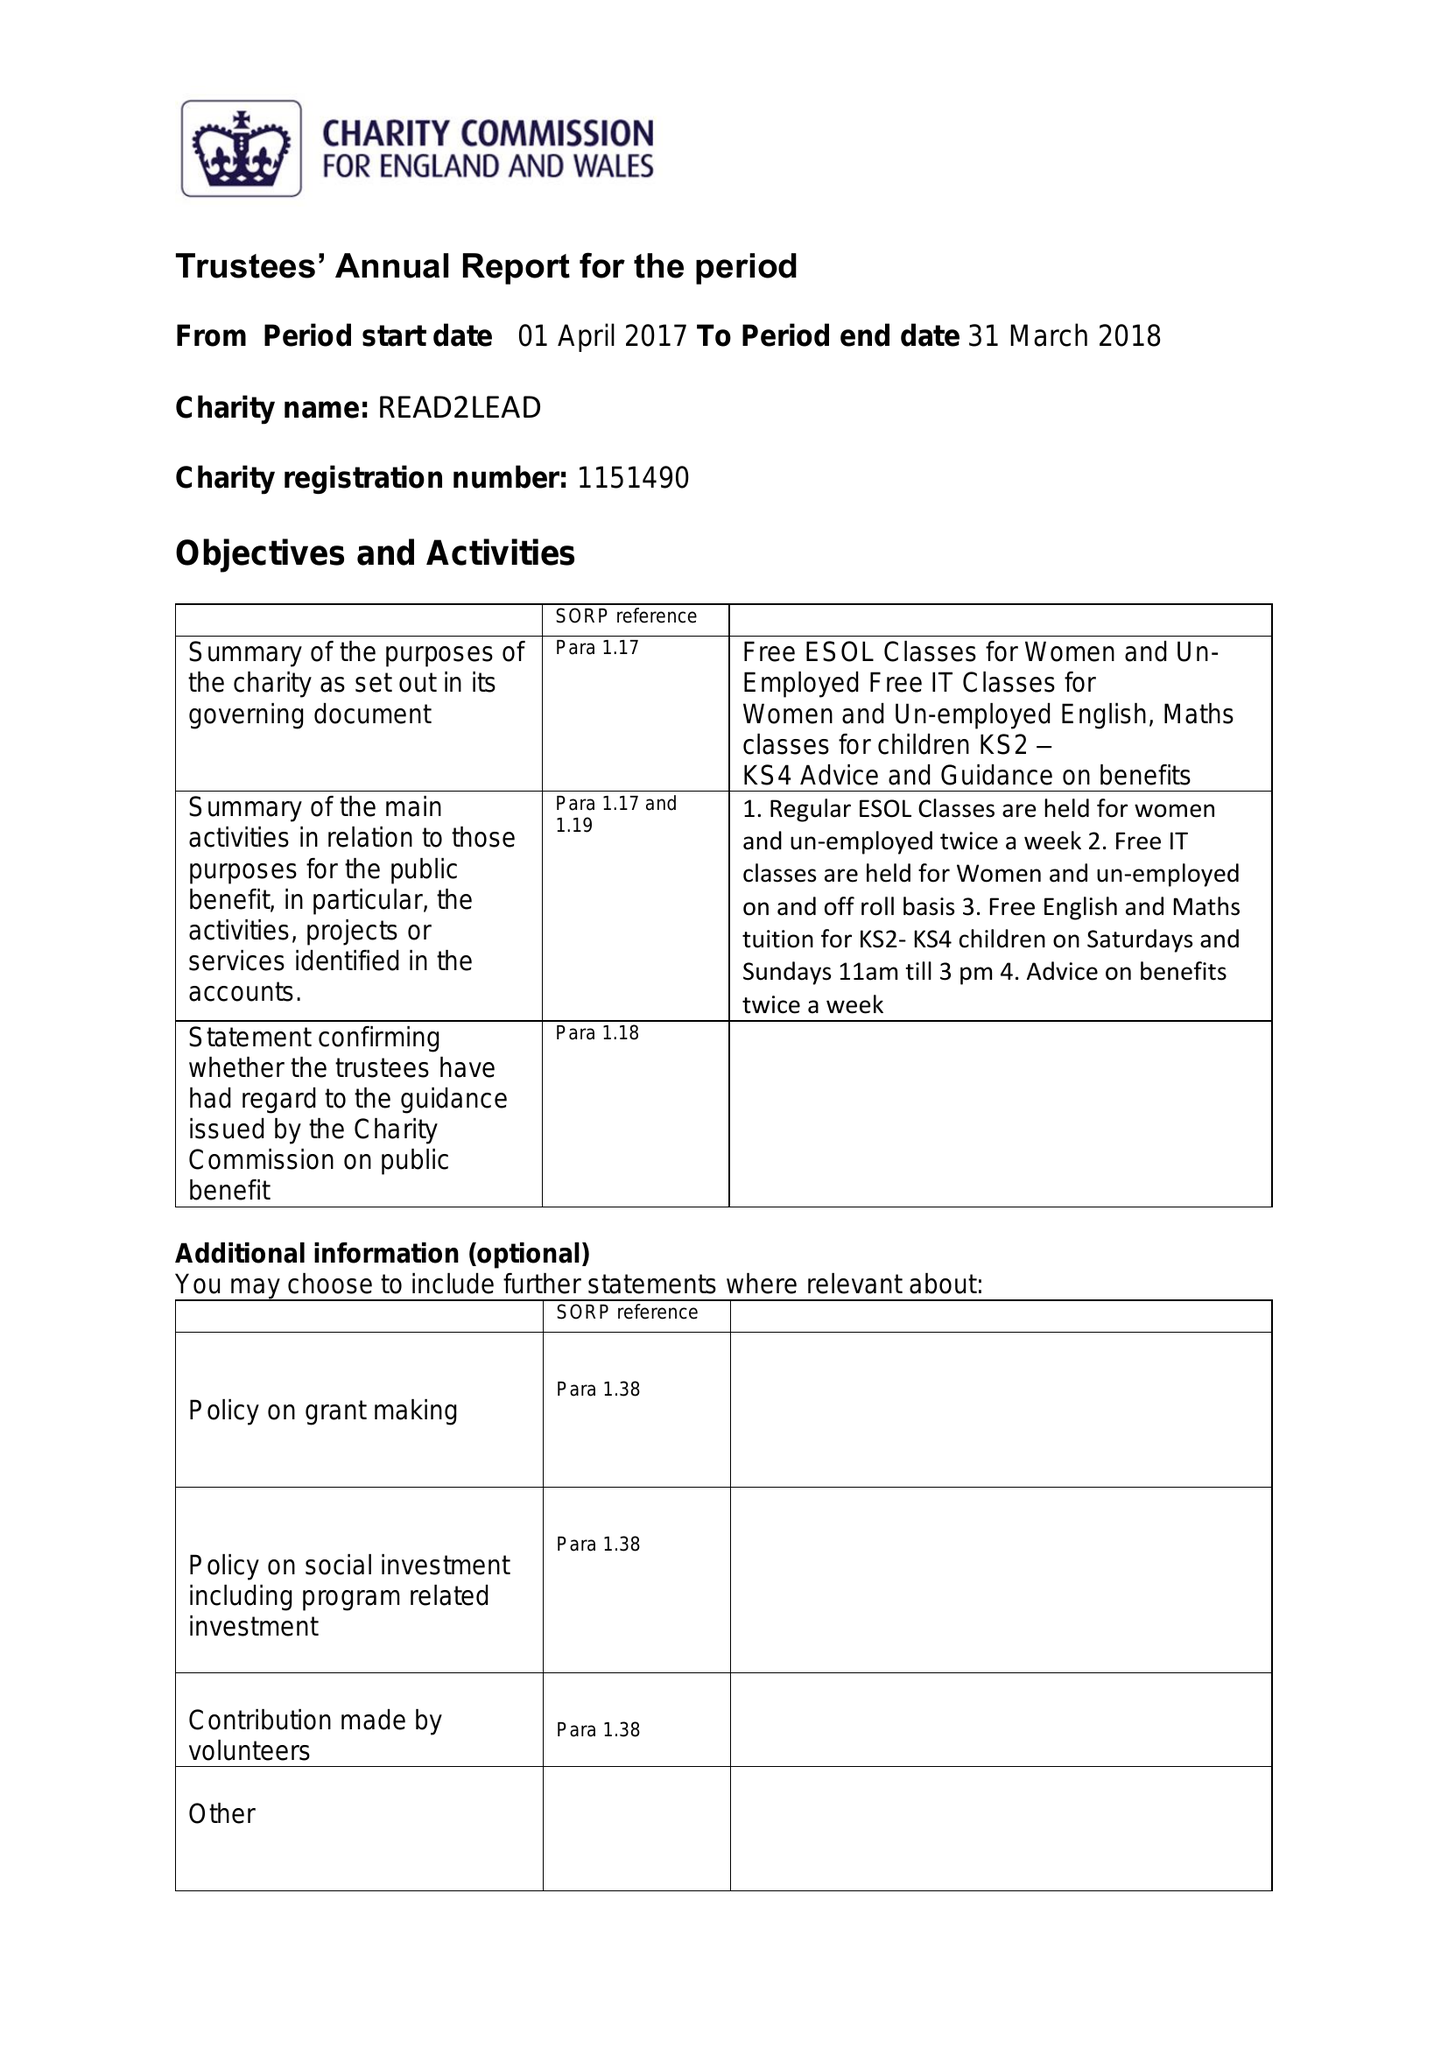What is the value for the address__street_line?
Answer the question using a single word or phrase. 43-45 WASHWOOD HEATH ROAD 